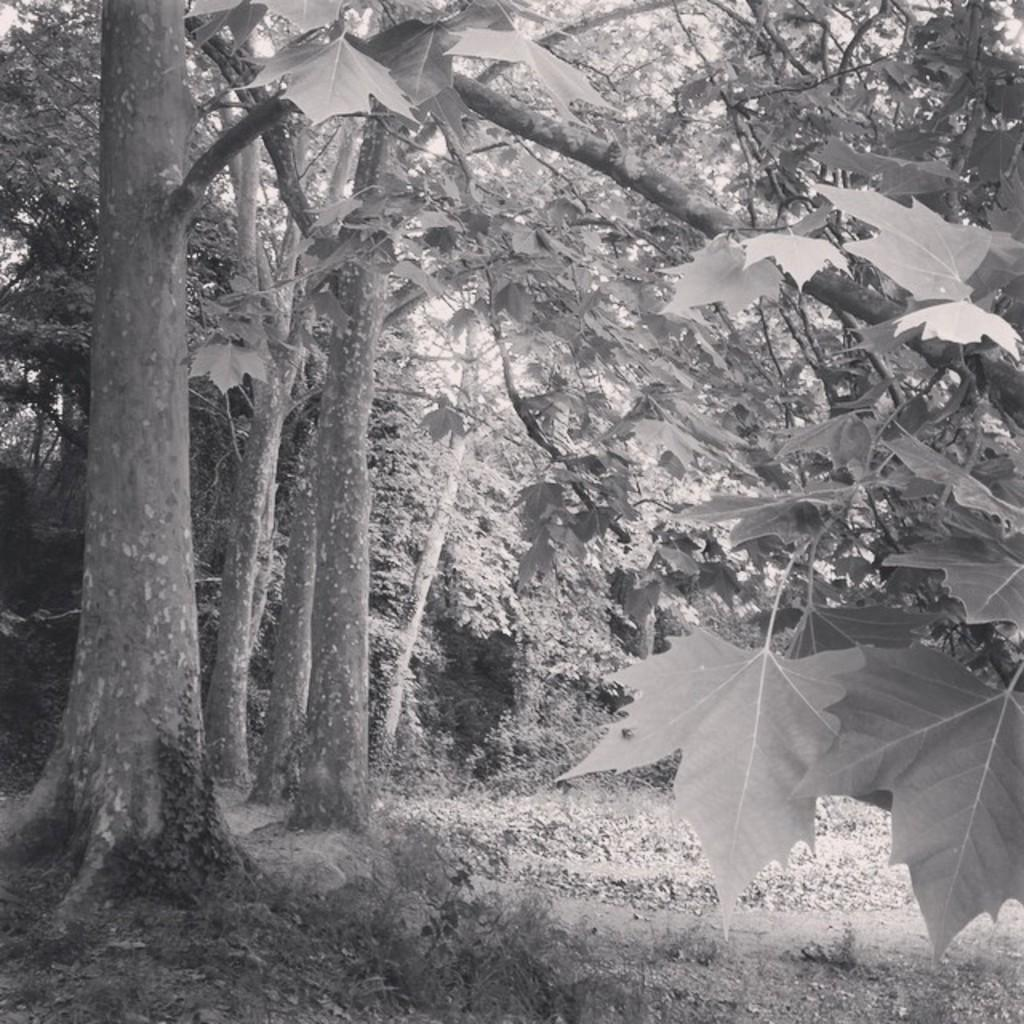What type of vegetation can be seen in the image? There is a group of trees and plants in the image. Can you describe the trees in the image? The group of trees in the image consists of multiple trees. What other types of vegetation are present in the image? In addition to the trees, there are plants in the image. What type of pain is being expressed by the trees in the image? There is no indication of pain in the image, as trees do not have the ability to express emotions or feelings. 